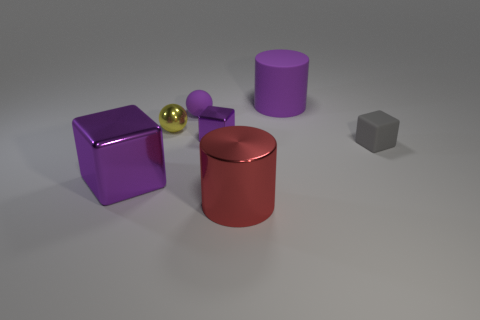Subtract 1 cubes. How many cubes are left? 2 Add 3 tiny yellow shiny cylinders. How many objects exist? 10 Subtract all blocks. How many objects are left? 4 Subtract 0 yellow cylinders. How many objects are left? 7 Subtract all small purple metal blocks. Subtract all small rubber spheres. How many objects are left? 5 Add 3 small matte spheres. How many small matte spheres are left? 4 Add 2 tiny green cylinders. How many tiny green cylinders exist? 2 